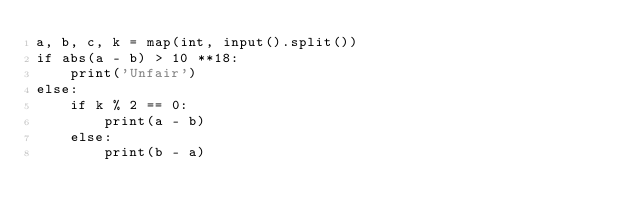<code> <loc_0><loc_0><loc_500><loc_500><_Python_>a, b, c, k = map(int, input().split())
if abs(a - b) > 10 **18:
    print('Unfair')
else:
    if k % 2 == 0:
        print(a - b)
    else:
        print(b - a)</code> 